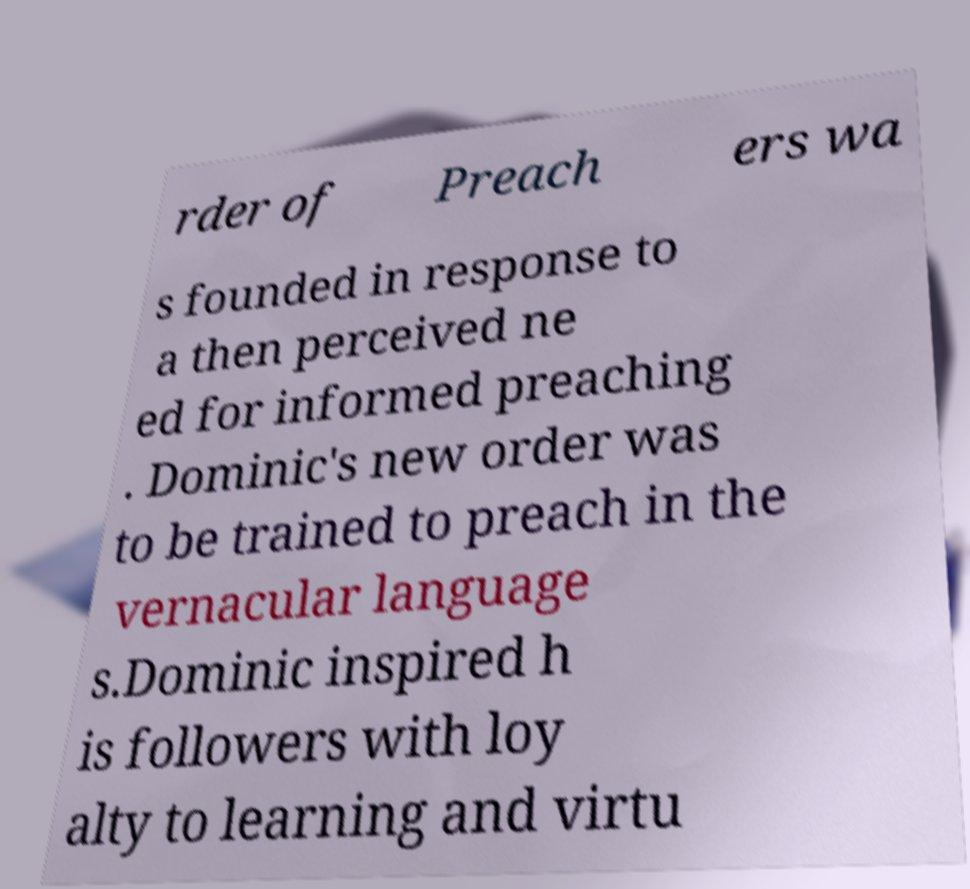Could you extract and type out the text from this image? rder of Preach ers wa s founded in response to a then perceived ne ed for informed preaching . Dominic's new order was to be trained to preach in the vernacular language s.Dominic inspired h is followers with loy alty to learning and virtu 